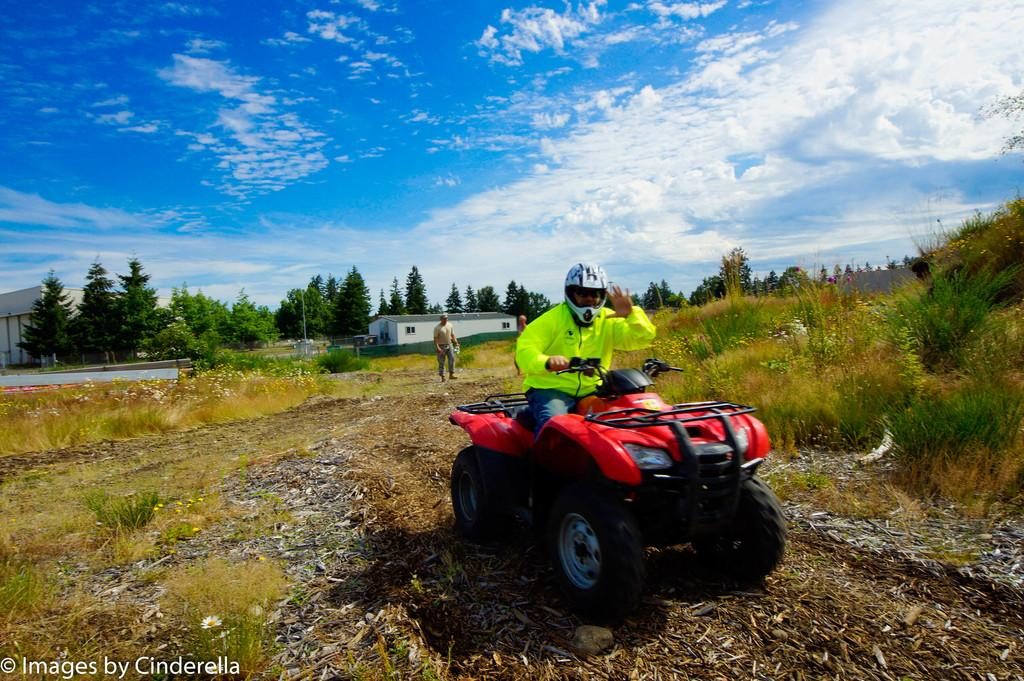What is the man in the image doing? The man is sitting on a vehicle in the image. What is the man wearing on his head? The man is wearing a helmet. What can be seen in the background of the image? There are buildings, trees, grass, and the sky visible in the background of the image. How many dimes can be seen on the tail of the vehicle in the image? There are no dimes visible on the vehicle in the image, nor is there any mention of a tail on the vehicle. Is the man in the image sleeping? The image does not provide any information about the man's state of consciousness, so it cannot be determined if he is sleeping or not. 